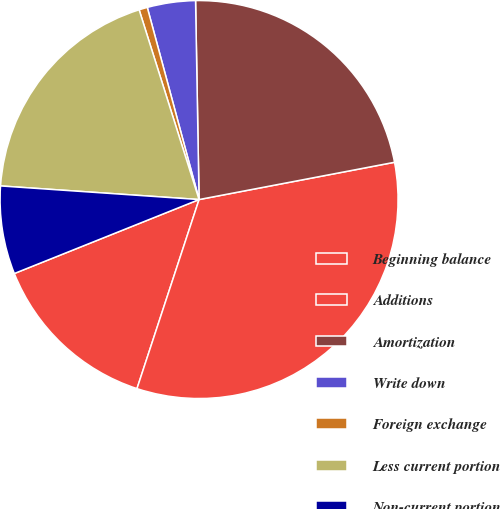<chart> <loc_0><loc_0><loc_500><loc_500><pie_chart><fcel>Beginning balance<fcel>Additions<fcel>Amortization<fcel>Write down<fcel>Foreign exchange<fcel>Less current portion<fcel>Non-current portion<nl><fcel>13.89%<fcel>33.05%<fcel>22.28%<fcel>3.91%<fcel>0.68%<fcel>19.04%<fcel>7.15%<nl></chart> 